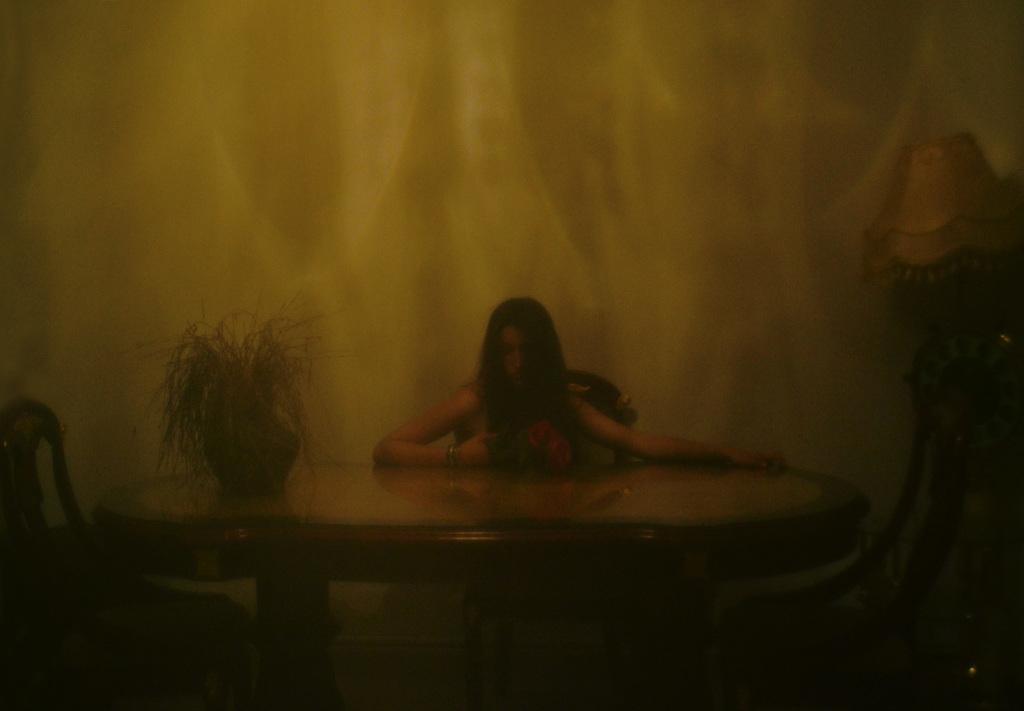Please provide a concise description of this image. In this picture we can see a girl sitting on a chair in front of a table, we can see a plant on the table, on the right side there is a lamp, we can see two more chairs here. 